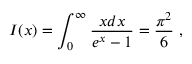<formula> <loc_0><loc_0><loc_500><loc_500>I ( x ) = \int _ { 0 } ^ { \infty } \frac { x d x } { e ^ { x } - 1 } = \frac { \pi ^ { 2 } } { 6 } ,</formula> 